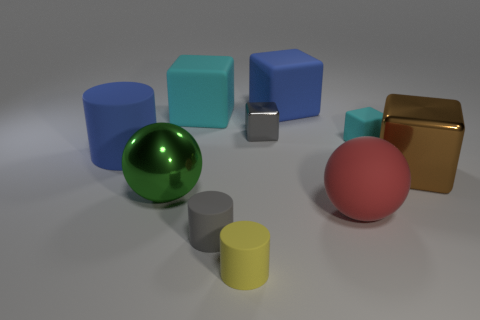What number of objects are either cyan rubber blocks that are to the right of the yellow rubber object or big rubber objects in front of the large blue matte cylinder?
Give a very brief answer. 2. Is the number of rubber objects that are behind the large red rubber sphere greater than the number of gray shiny objects?
Ensure brevity in your answer.  Yes. What number of other brown objects are the same size as the brown thing?
Give a very brief answer. 0. Do the cylinder that is behind the red rubber object and the matte cube left of the tiny yellow thing have the same size?
Give a very brief answer. Yes. There is a cyan matte block that is to the left of the big red ball; what size is it?
Ensure brevity in your answer.  Large. How big is the gray object behind the blue object left of the big blue block?
Your answer should be compact. Small. There is a cylinder that is the same size as the brown shiny thing; what is it made of?
Your answer should be very brief. Rubber. There is a gray metal thing; are there any red matte things behind it?
Keep it short and to the point. No. Is the number of yellow things to the right of the yellow thing the same as the number of large yellow matte blocks?
Make the answer very short. Yes. There is a red object that is the same size as the brown block; what is its shape?
Keep it short and to the point. Sphere. 